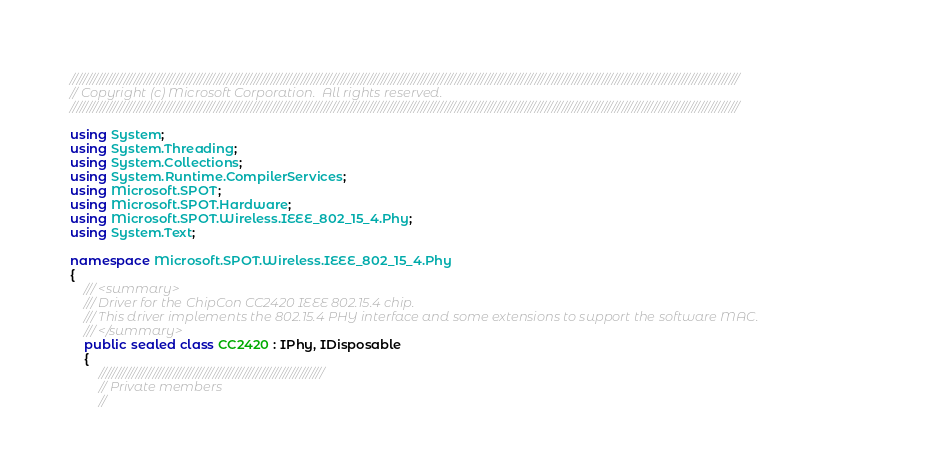Convert code to text. <code><loc_0><loc_0><loc_500><loc_500><_C#_>////////////////////////////////////////////////////////////////////////////////////////////////////////////////////////////////////////////////////////////////////////////////////////////////////////
// Copyright (c) Microsoft Corporation.  All rights reserved.
////////////////////////////////////////////////////////////////////////////////////////////////////////////////////////////////////////////////////////////////////////////////////////////////////////

using System;
using System.Threading;
using System.Collections;
using System.Runtime.CompilerServices;
using Microsoft.SPOT;
using Microsoft.SPOT.Hardware;
using Microsoft.SPOT.Wireless.IEEE_802_15_4.Phy;
using System.Text;

namespace Microsoft.SPOT.Wireless.IEEE_802_15_4.Phy
{
    /// <summary>
    /// Driver for the ChipCon CC2420 IEEE 802.15.4 chip.
    /// This driver implements the 802.15.4 PHY interface and some extensions to support the software MAC.
    /// </summary>
    public sealed class CC2420 : IPhy, IDisposable
    {
        ///////////////////////////////////////////////////////////////////
        // Private members
        //</code> 